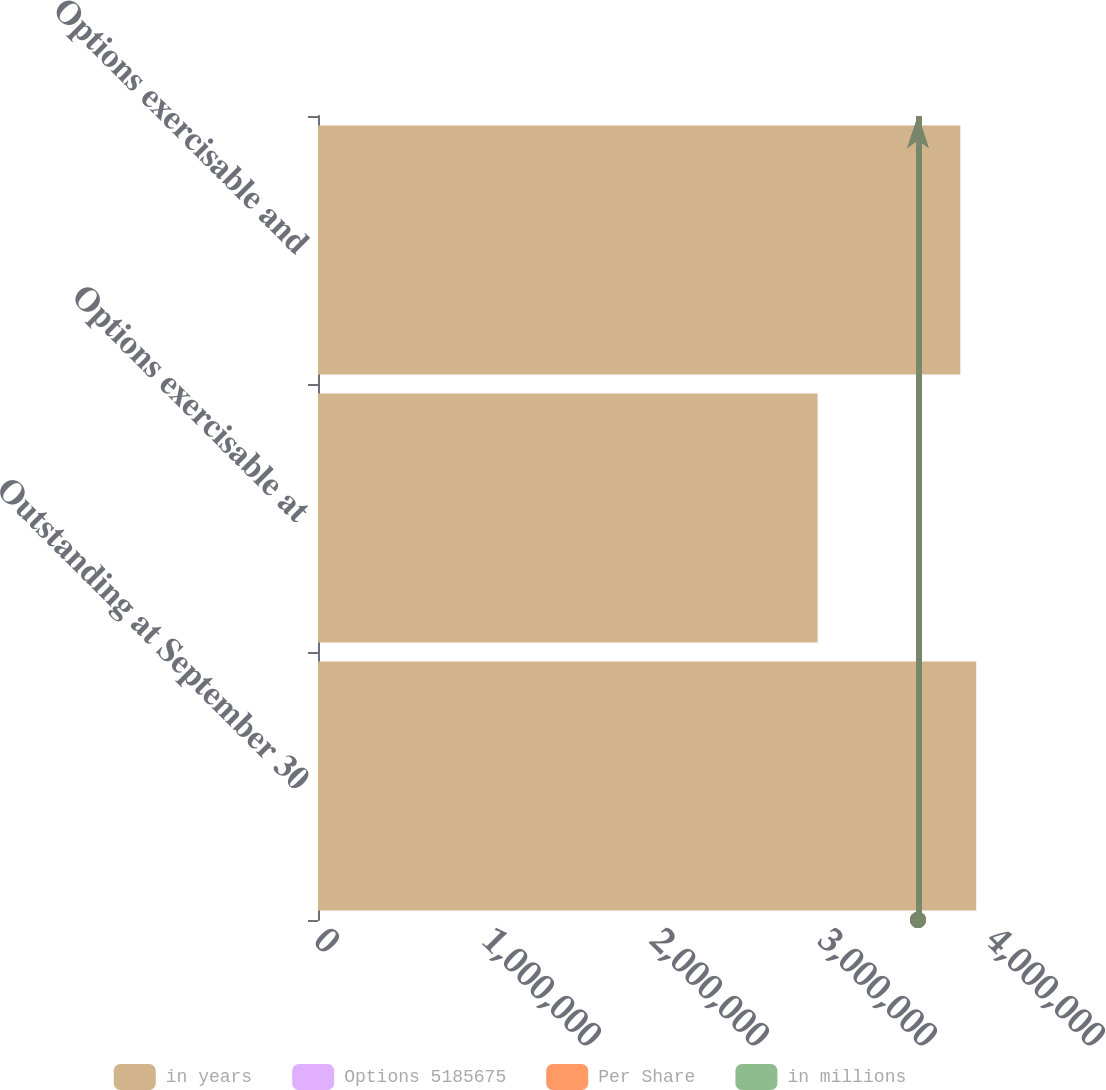Convert chart. <chart><loc_0><loc_0><loc_500><loc_500><stacked_bar_chart><ecel><fcel>Outstanding at September 30<fcel>Options exercisable at<fcel>Options exercisable and<nl><fcel>in years<fcel>3.91721e+06<fcel>2.97342e+06<fcel>3.82283e+06<nl><fcel>Options 5185675<fcel>72.21<fcel>57.74<fcel>71.08<nl><fcel>Per Share<fcel>5.7<fcel>4.8<fcel>5.6<nl><fcel>in millions<fcel>466<fcel>397<fcel>459<nl></chart> 